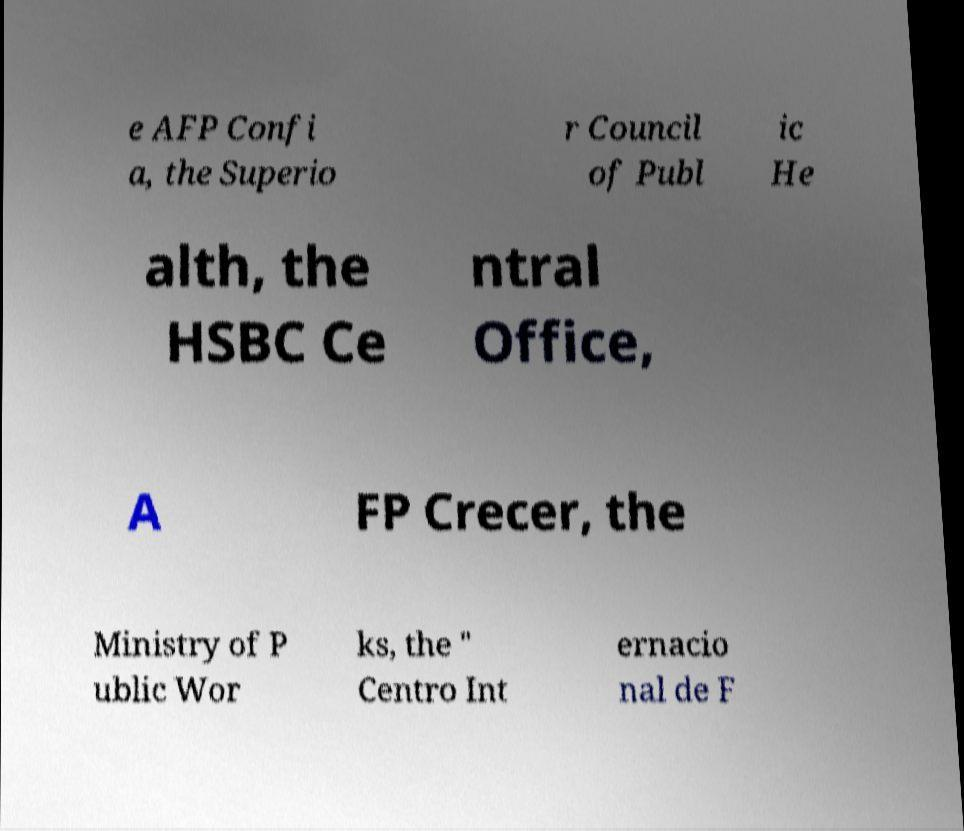I need the written content from this picture converted into text. Can you do that? e AFP Confi a, the Superio r Council of Publ ic He alth, the HSBC Ce ntral Office, A FP Crecer, the Ministry of P ublic Wor ks, the " Centro Int ernacio nal de F 